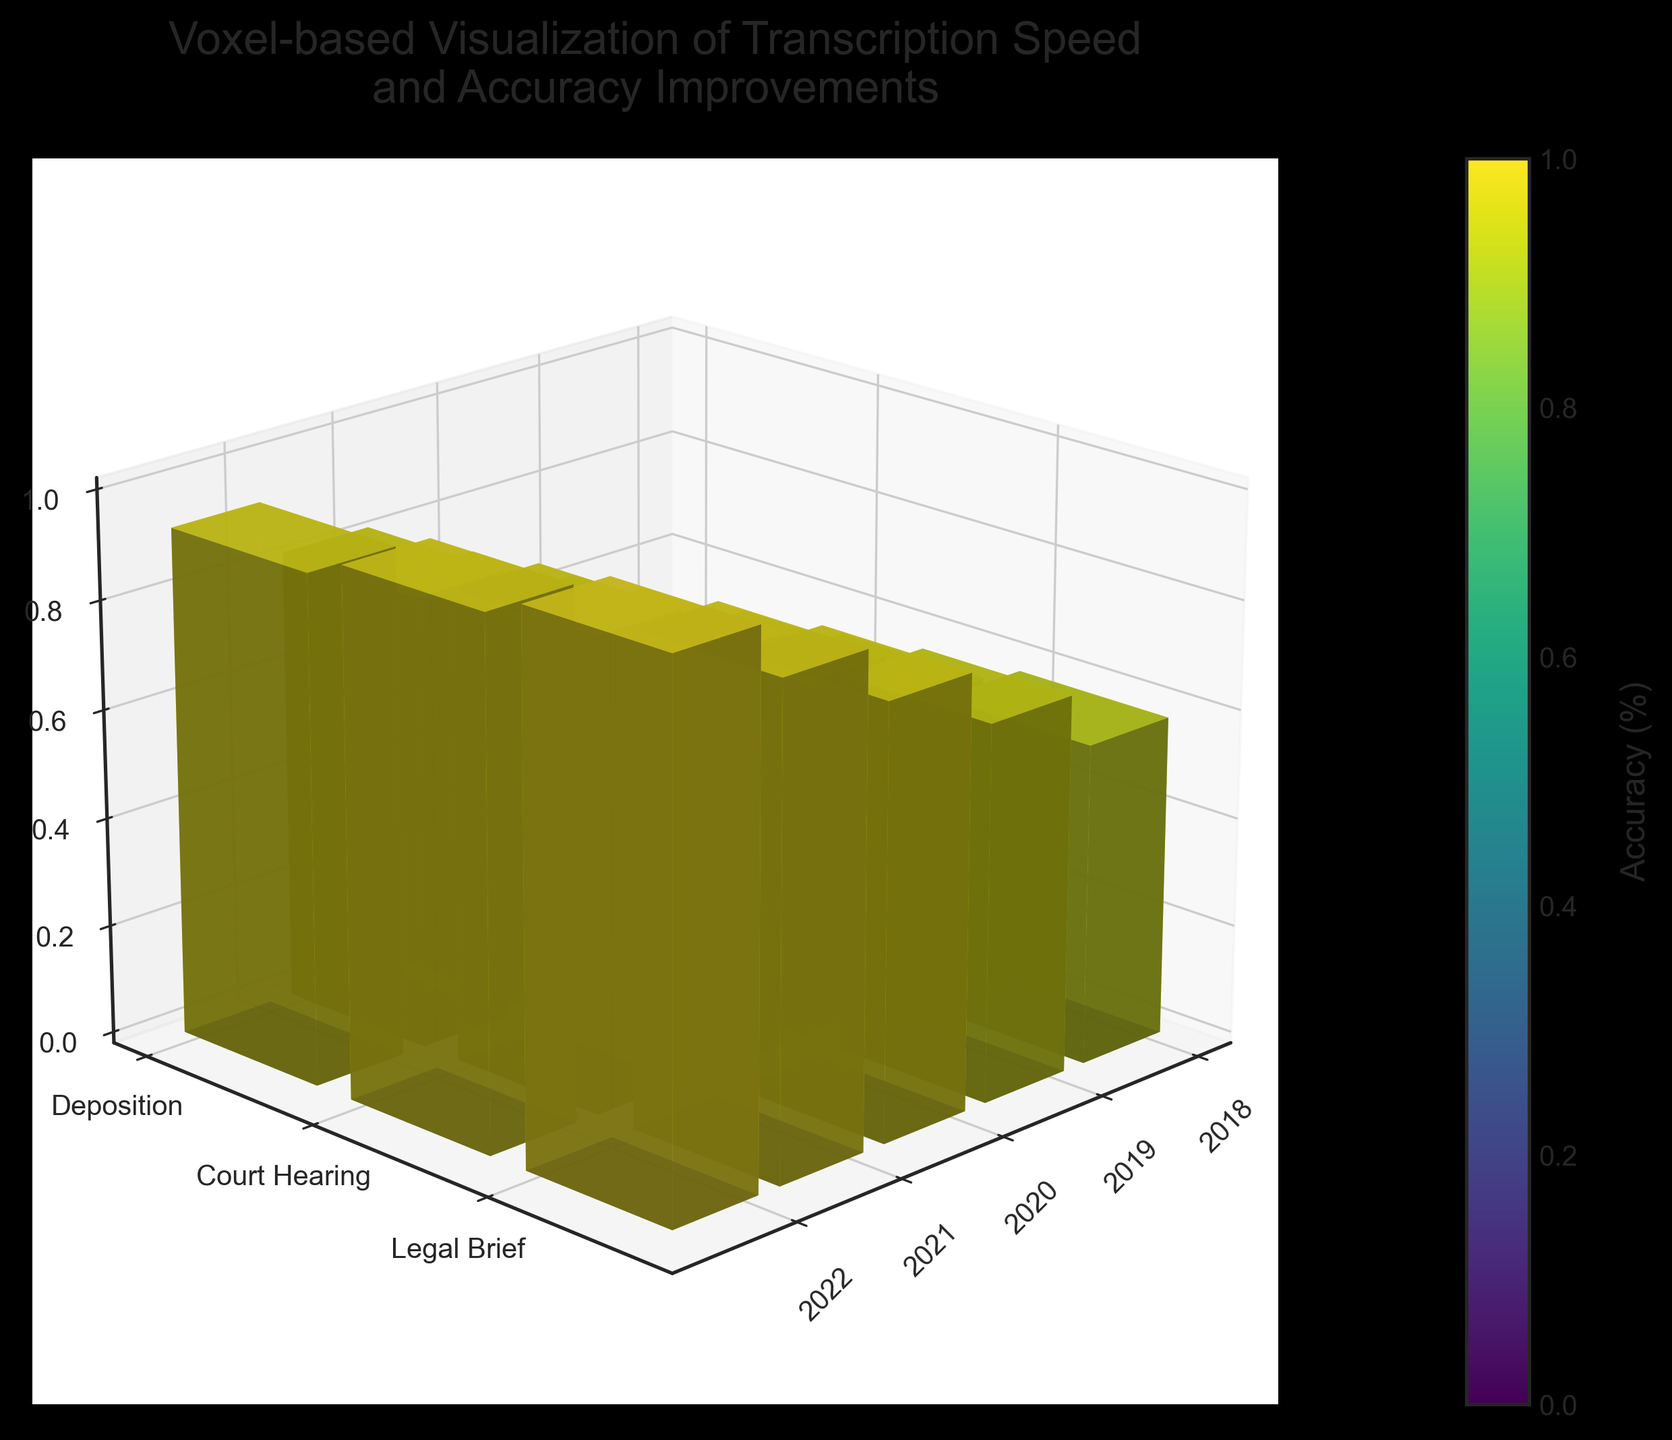How many different years are represented in the figure? The x-axis of the 3D voxel plot represents different years. By counting the labels along the x-axis, we observe that years 2018, 2019, 2020, 2021, and 2022 are represented.
Answer: 5 Does the transcription speed of "Court Hearing" improve consistently over the years? By examining the heights of the voxels labeled "Court Hearing" on the y-axis across the years on the x-axis, the heights increase from 75 wpm in 2018 to 135 wpm in 2022, indicating consistent improvement.
Answer: Yes What is the color scheme used to represent accuracy and what does it imply? The color scheme used is a gradient scale from the viridis colormap. Lighter colors represent higher accuracy percentages, while darker colors represent lower accuracy percentages.
Answer: Viridis, higher accuracy is lighter Which document type had the highest transcription speed in 2020? By observing the height of the voxels for all document types in the year 2020 along the x-axis, "Legal Brief" has the tallest voxel, indicating the highest transcription speed of 115 words per minute.
Answer: Legal Brief What is the range of transcription speeds for depositions over the years? Looking at the heights of the voxels for "Deposition" across all years on the x-axis, the speeds go from 80 wpm in 2018 to 140 wpm in 2022. Therefore, the range is 140 - 80 = 60 wpm.
Answer: 60 wpm Compare the improvement in transcription speed of "Legal Brief" from 2018 to 2022 with the improvement in accuracy. In 2018, the speed for "Legal Brief" is 85 wpm and in 2022 it is 145 wpm, an improvement of 60 wpm (145 - 85). Accuracy improved from 93% to 99%, an improvement of 6%.
Answer: 60 wpm, 6% Which document type had the most consistent accuracy improvement over the years? By examining the color changes in voxels representing accuracy for each document type, "Legal Brief" shows a gradual consistent change towards lighter colors, indicating a steady improvement.
Answer: Legal Brief In 2019, which document type had the highest accuracy and what was it? By looking at the color scheme for the year 2019, "Legal Brief" has the lightest color among all document types, representing the highest accuracy of 95%.
Answer: Legal Brief, 95% How does the z-axis label help in understanding the 3D plot? The z-axis label indicates "Transcription Speed (words per minute)," which helps in interpreting the height of the voxels as transcription speed for different document types and years.
Answer: It shows transcription speed 